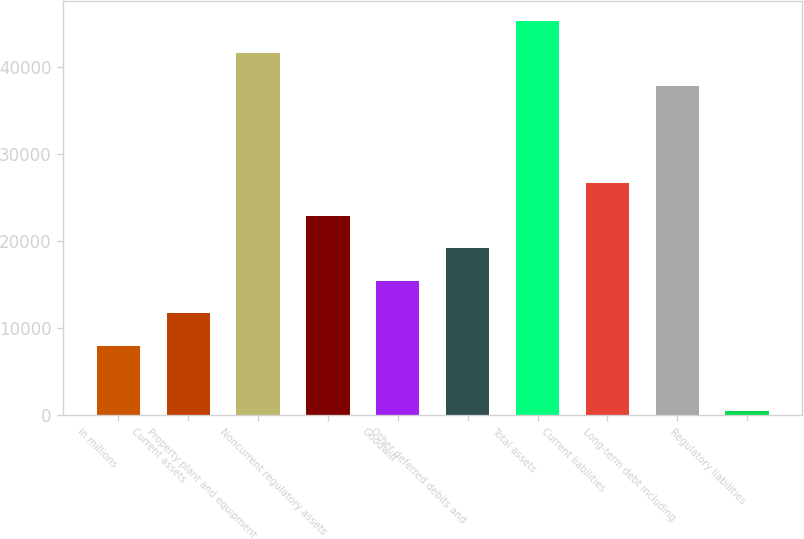<chart> <loc_0><loc_0><loc_500><loc_500><bar_chart><fcel>in millions<fcel>Current assets<fcel>Property plant and equipment<fcel>Noncurrent regulatory assets<fcel>Goodwill<fcel>Other deferred debits and<fcel>Total assets<fcel>Current liabilities<fcel>Long-term debt including<fcel>Regulatory liabilities<nl><fcel>7962.6<fcel>11700.9<fcel>41607.3<fcel>22915.8<fcel>15439.2<fcel>19177.5<fcel>45345.6<fcel>26654.1<fcel>37869<fcel>486<nl></chart> 